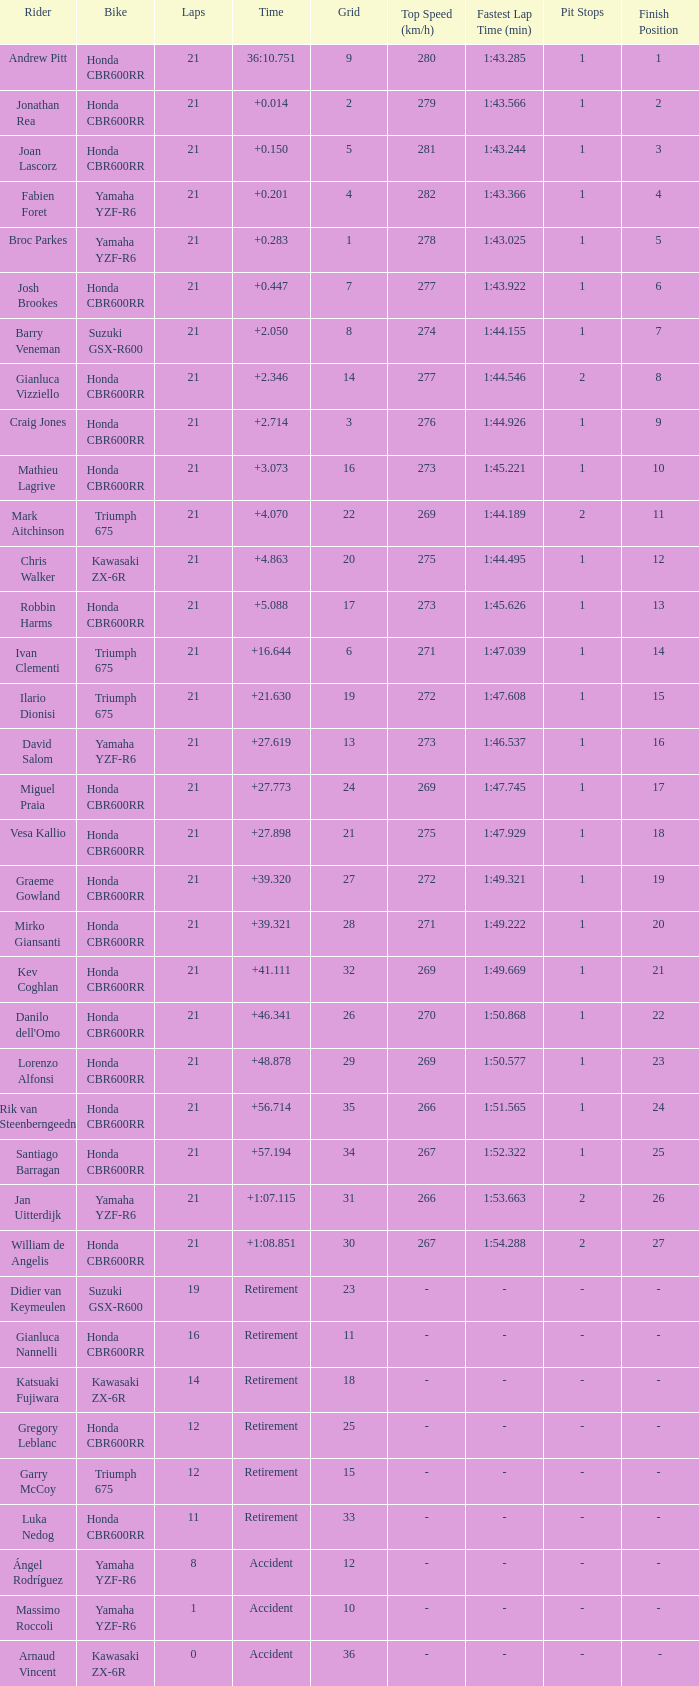What is the most number of laps run by Ilario Dionisi? 21.0. 